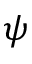<formula> <loc_0><loc_0><loc_500><loc_500>\psi</formula> 